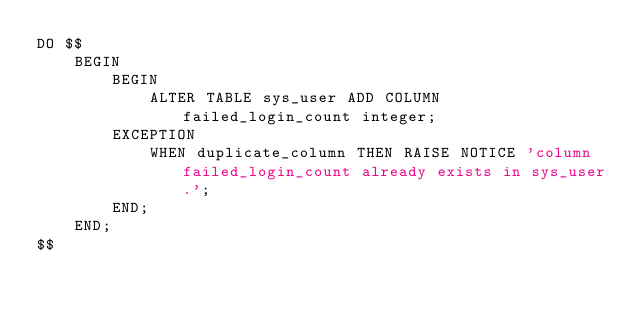Convert code to text. <code><loc_0><loc_0><loc_500><loc_500><_SQL_>DO $$
    BEGIN
        BEGIN
            ALTER TABLE sys_user ADD COLUMN failed_login_count integer;
        EXCEPTION
            WHEN duplicate_column THEN RAISE NOTICE 'column failed_login_count already exists in sys_user.';
        END;
    END;
$$
</code> 